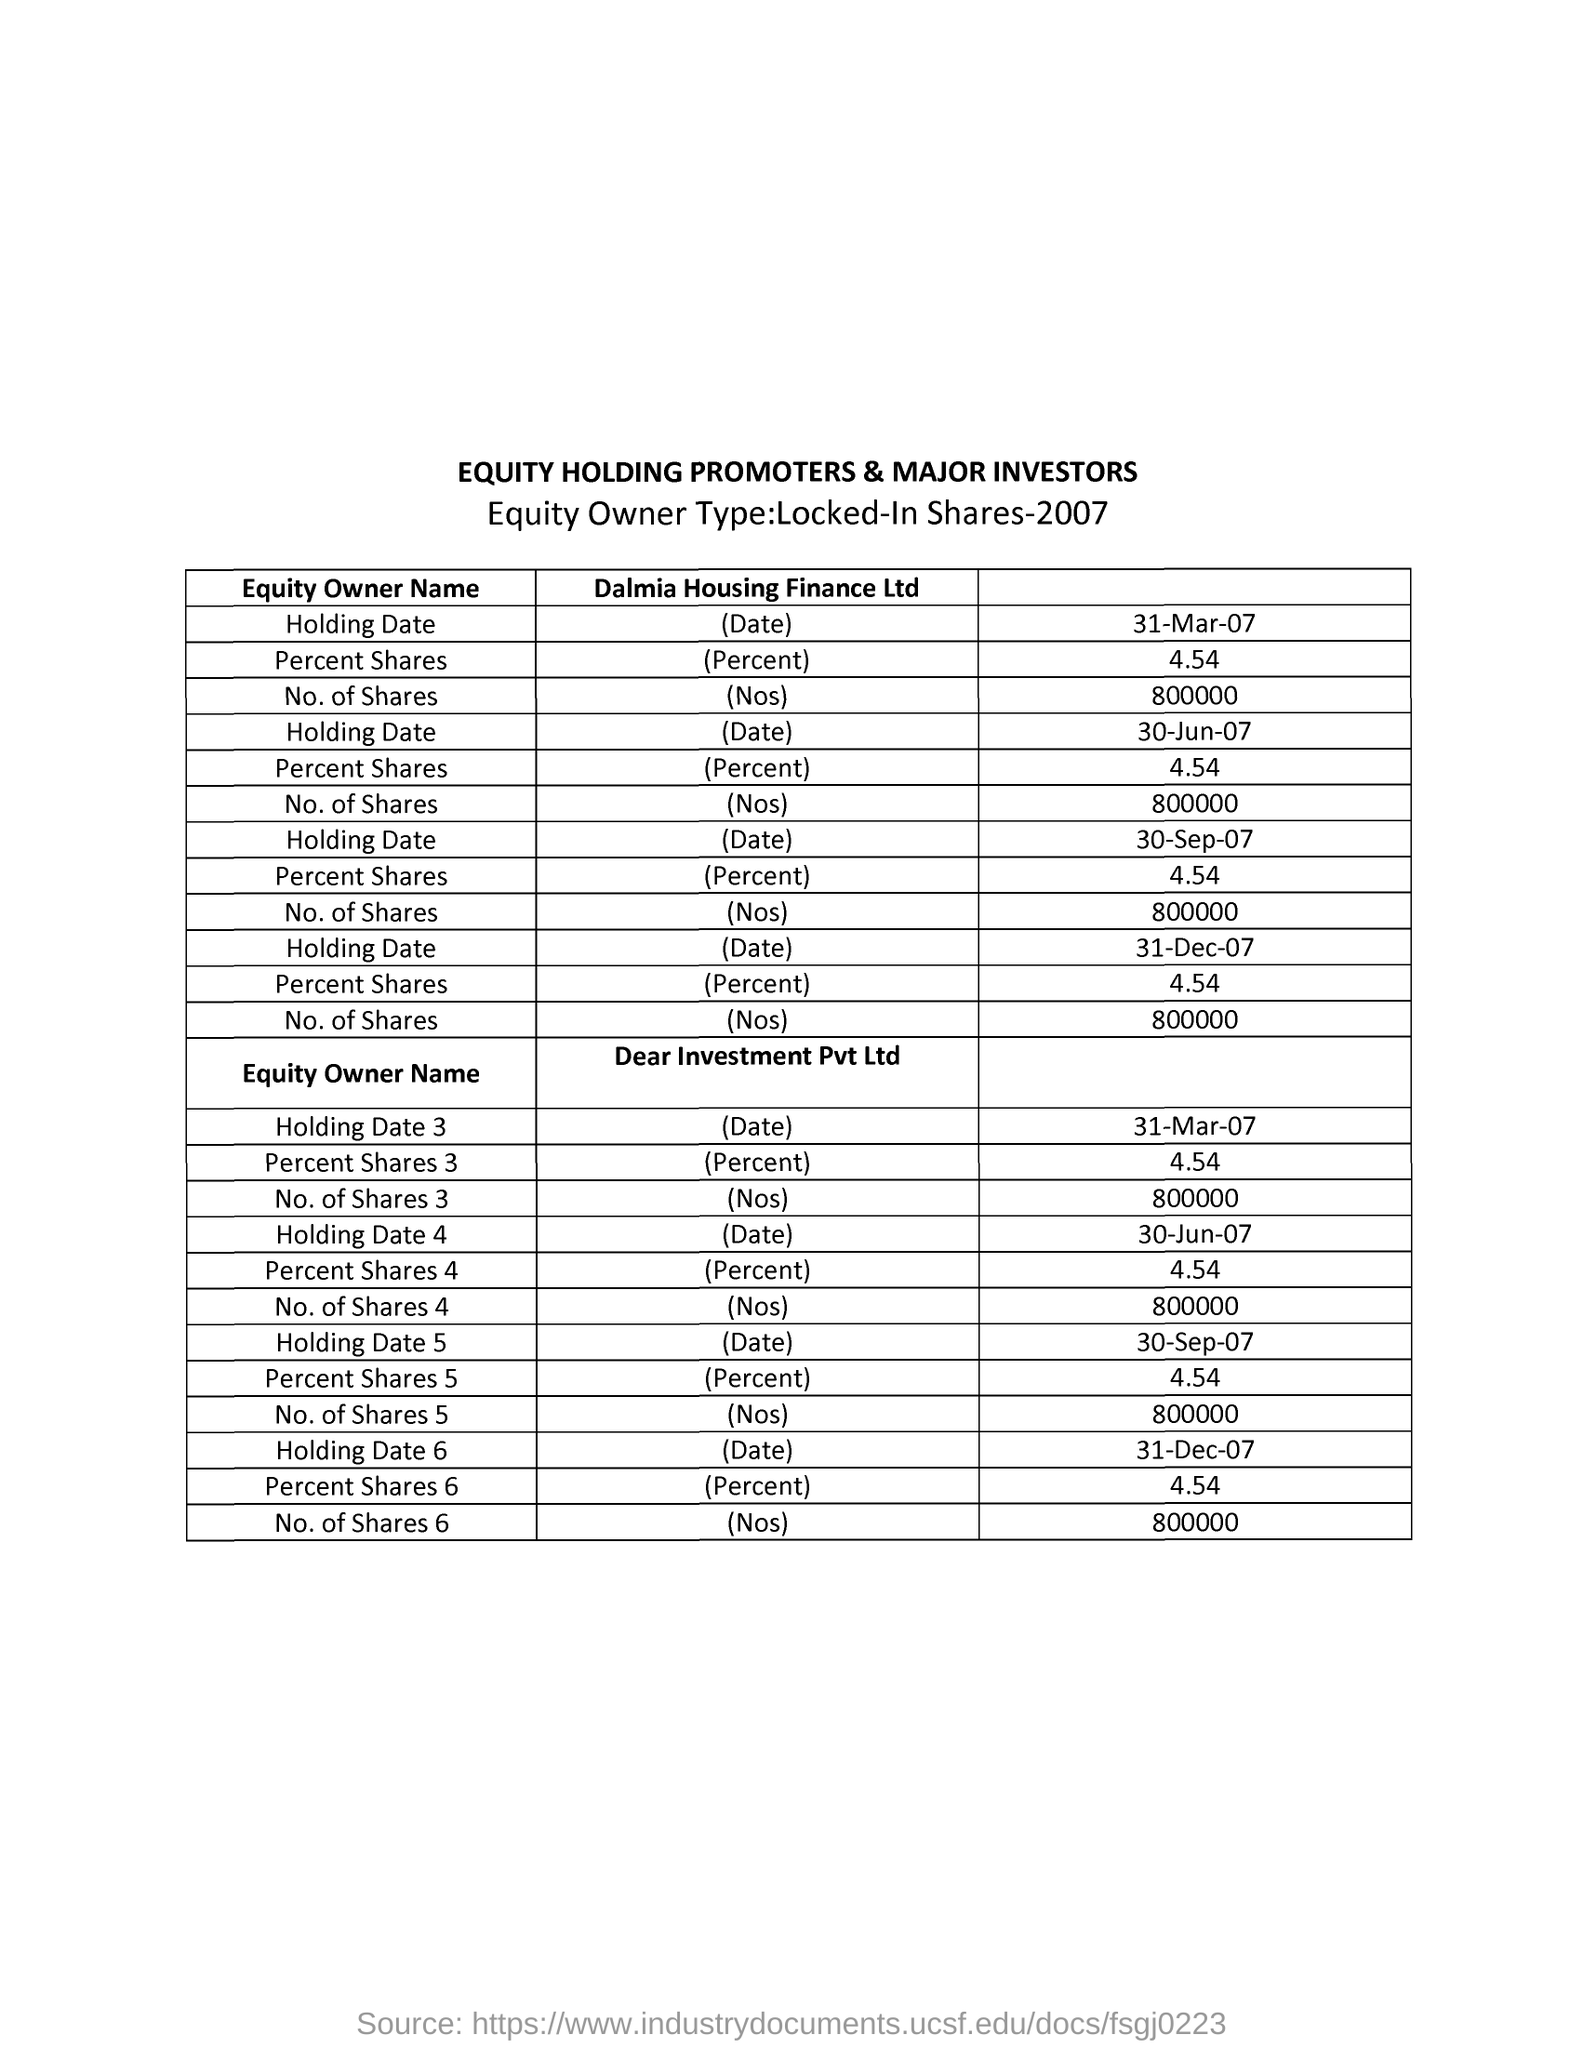What is the heading  given to the first column  of the table?
Offer a terse response. Equity Owner Name. Mention the heading given to the table in capital letters?
Make the answer very short. EQUITY HOLDING PROMOTERS & MAJOR INVESTORS. What is the "Equity Owner Type:" mentioned?
Your answer should be very brief. Locked-In Shares-2007. "Locked-In Shares" details  of which year is given in the table?
Your answer should be very brief. 2007. What is the heading given to the second column of the first table?
Give a very brief answer. Dalmia Housing Finance Ltd. What is the first field entered under "Equity Owner Name" of Dalmia Housing Finance Ltd in the table?
Your answer should be very brief. Holding Date. What is the first field entered under "Equity Owner Name" of Dear Investment Pvt Ltd in the table?
Your answer should be compact. Holding Date 3. What is the value of "Percent Shares" given to all Equity owners?
Your answer should be compact. 4.54. What is the  number of Shares of all Equity owners?
Keep it short and to the point. 800000. 